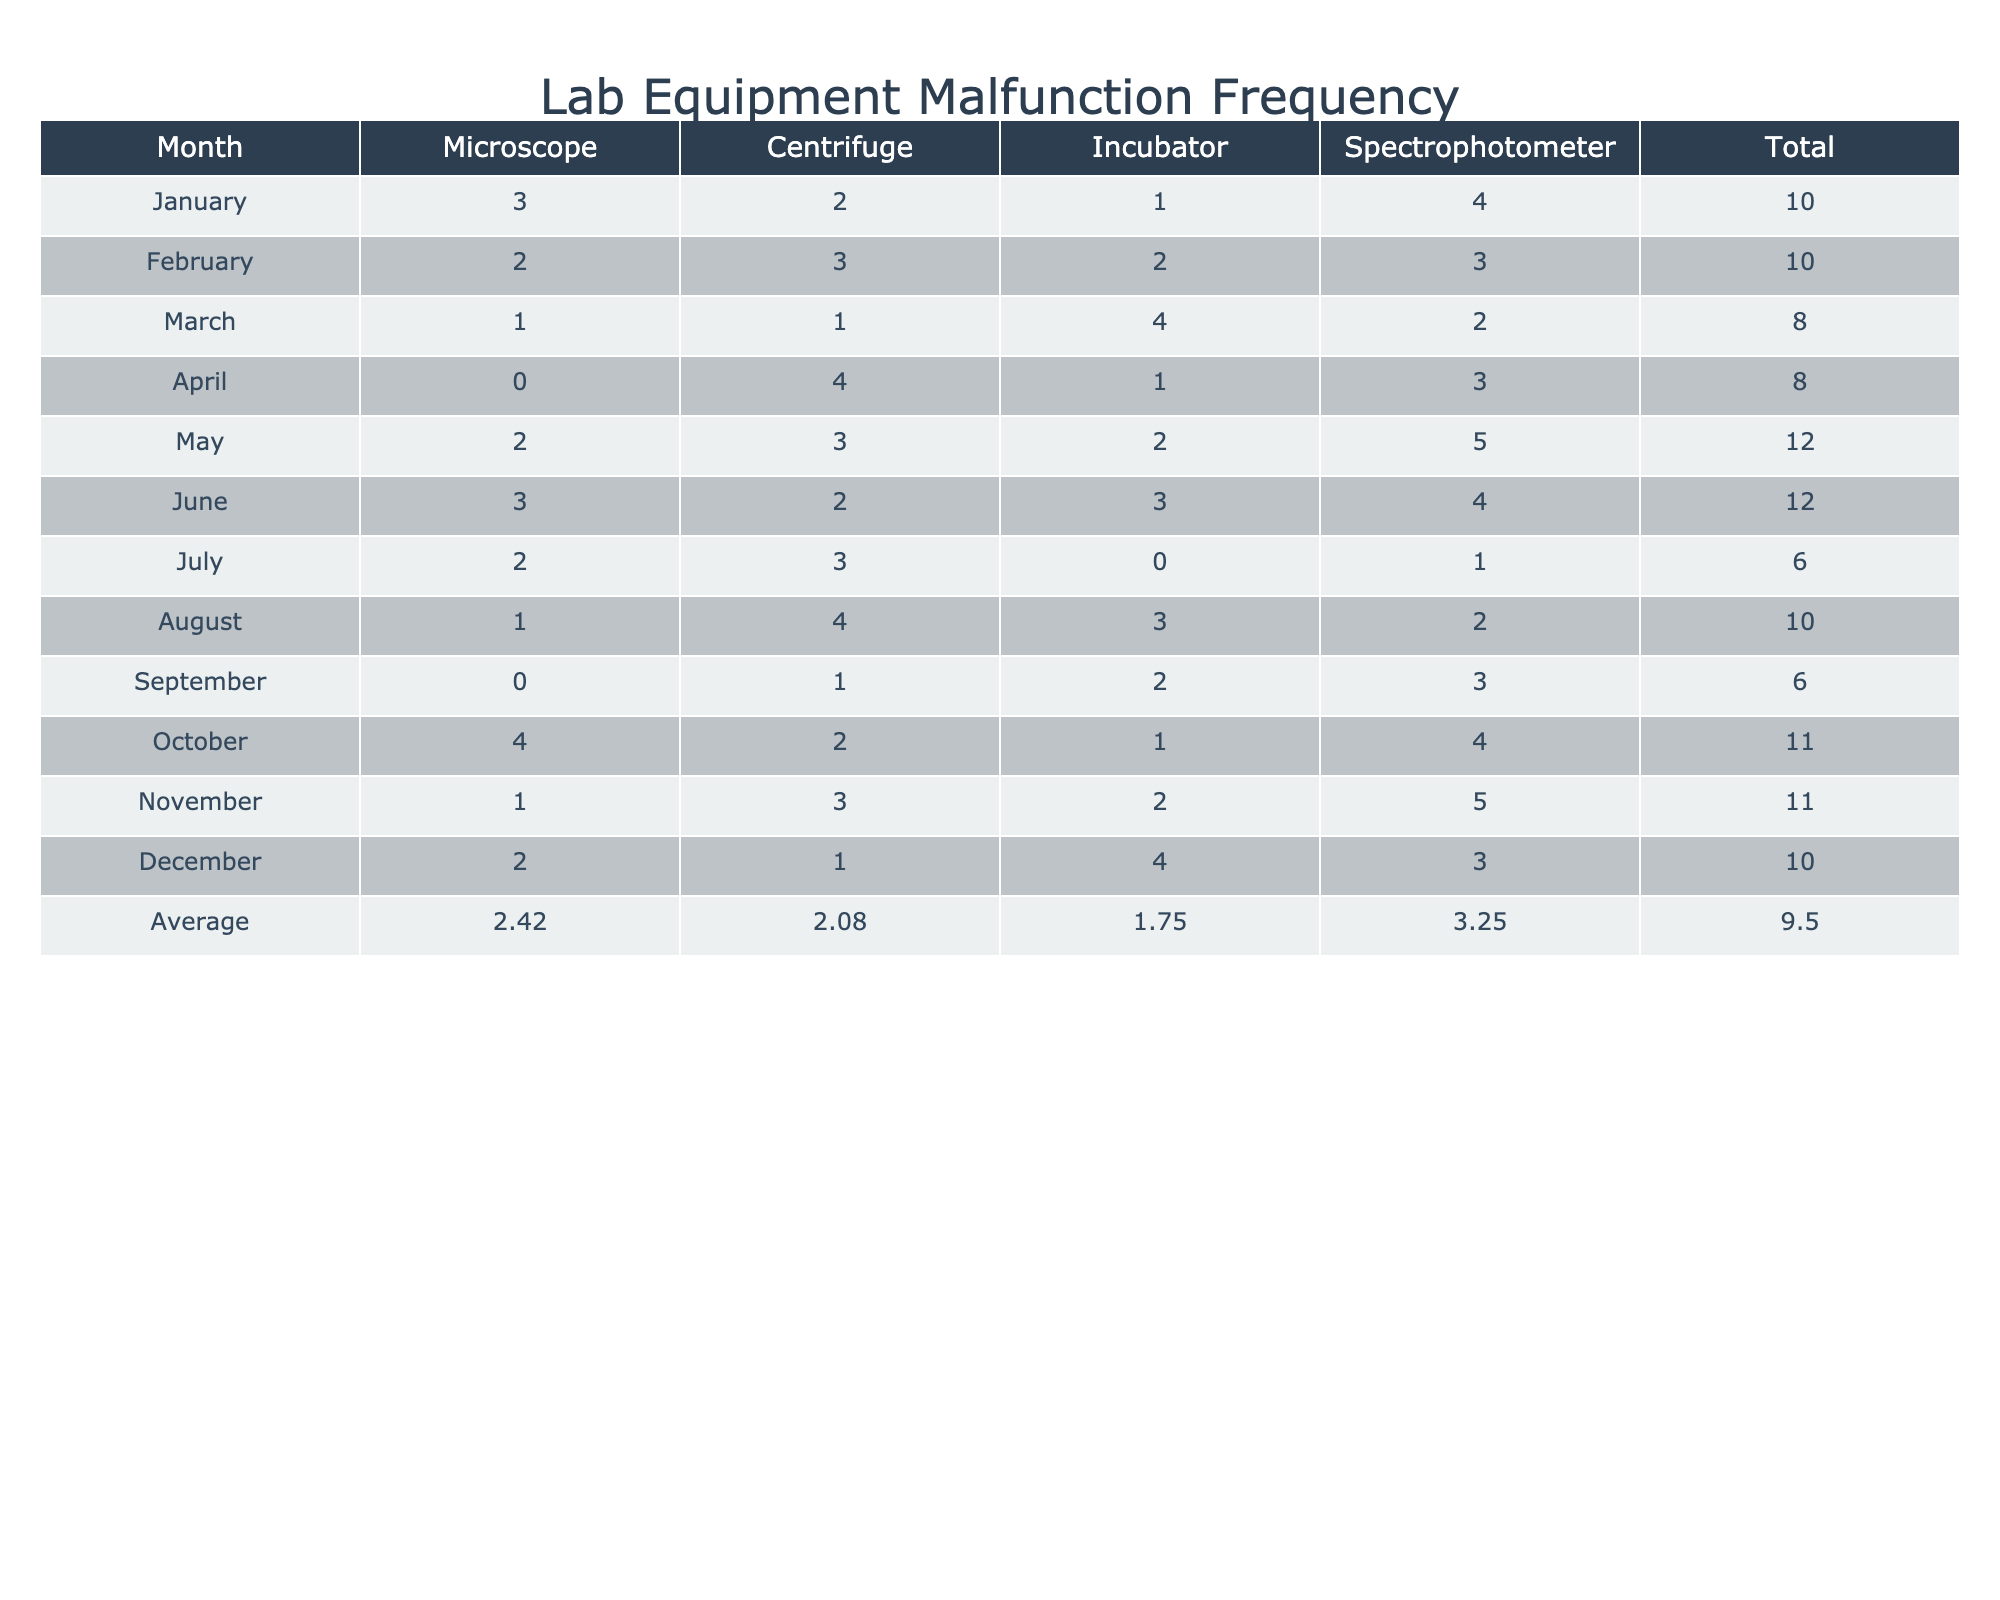What is the malfunction frequency of the Centrifuge in April? In the table, I look for the row corresponding to April and locate the value under the Centrifuge equipment type, which is 4.
Answer: 4 Which equipment type had the highest malfunction frequency in December? Checking the December row, I see the frequencies for all equipment types. The Spectrophotometer has the highest at 3.
Answer: Spectrophotometer What is the average malfunction frequency for Incubators across all months? To find the average, I first sum the malfunction frequencies for Incubators: 1 + 2 + 4 + 1 + 2 + 3 + 0 + 3 + 2 + 1 + 4 = 24. There are 12 months, so the average is 24/12 = 2.
Answer: 2 Did the Microscope ever have a malfunction frequency of 0? I look through all the months and find that in April and September, the Microscope had a frequency of 0. This means the statement is true.
Answer: Yes In which month did the Spectrophotometer have the highest frequency, and what was that frequency? I check each row for the Spectrophotometer and find that May has the highest frequency at 5.
Answer: May, 5 What is the total malfunction frequency for July across all equipment types? I sum the frequency values of all equipment types in July: 2 + 3 + 0 + 1 = 6.
Answer: 6 Which month had the lowest total malfunction frequency? To determine this, I calculate the total for each month. The totals are: January 10, February 10, March 8, April 8, May 12, June 12, July 6, August 10, September 6, October 11, November 11, December 10. The two lowest totals are for July and September, both of which are 6.
Answer: July and September What is the difference in malfunction frequency for the Centrifuge between the months with its lowest and highest frequency? I find the lowest malfunction frequency for the Centrifuge is 1 (September) and the highest is 4 (April). The difference is 4 - 1 = 3.
Answer: 3 